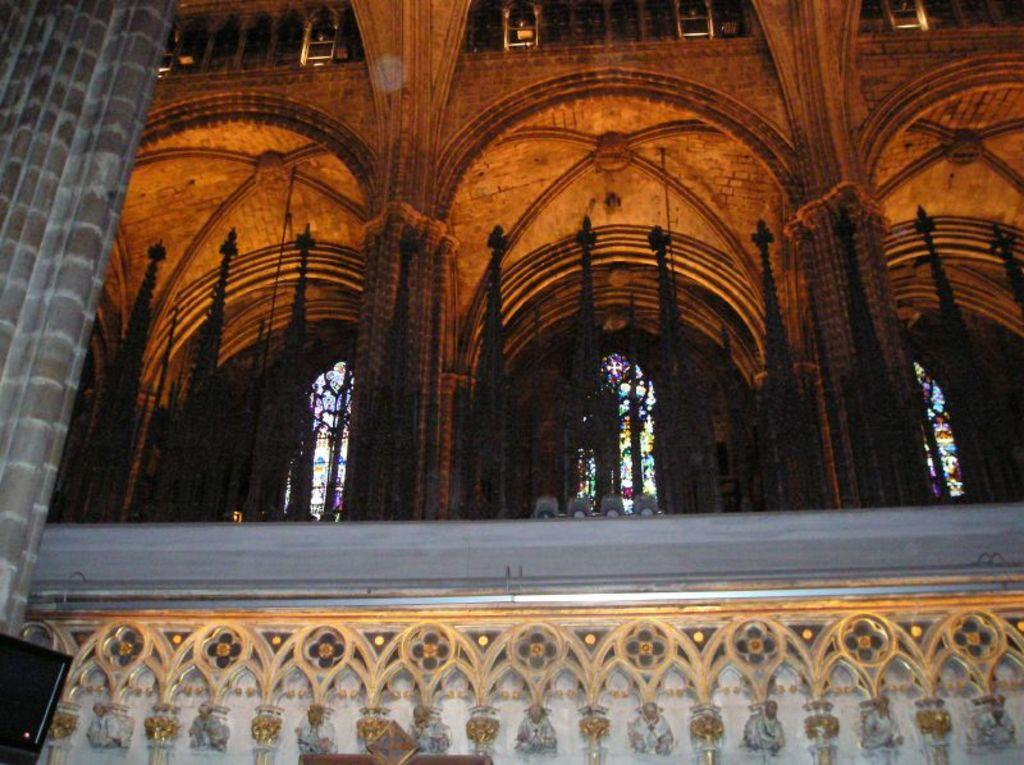What type of design can be seen on the wall in the image? There is a wall with designs in the image. What architectural features are present above the wall? There are arches with fencing above the wall. Where is the pillar located in the image? There is a pillar in the left corner of the image. Can you see any errors in the design of the wall in the image? There is no mention of any errors in the design of the wall in the image, and we cannot assume the presence of errors based on the provided facts. Is there a garden visible in the image? There is no mention of a garden in the image, so we cannot confirm its presence. 